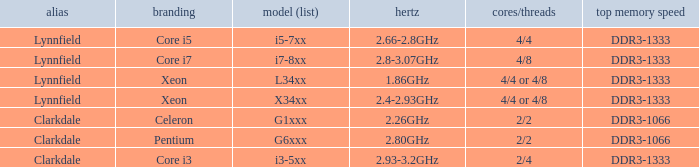What frequency does model L34xx use? 1.86GHz. 